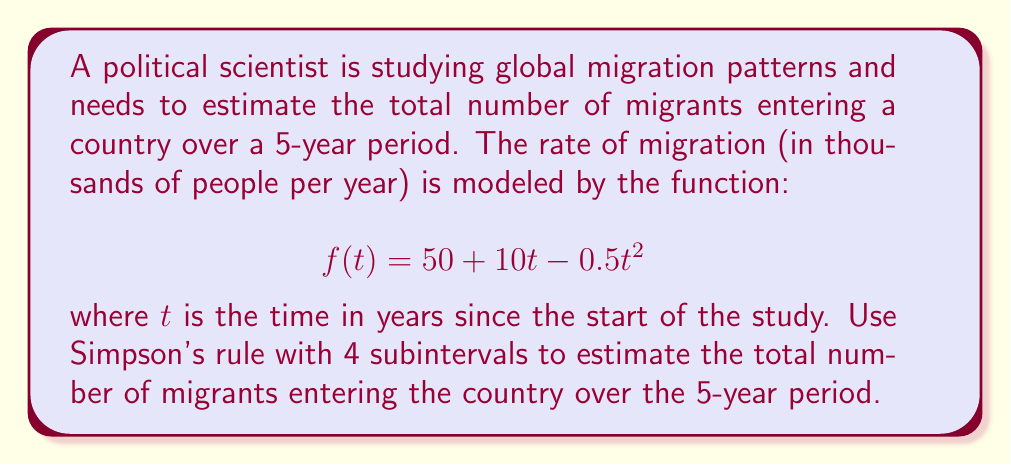Could you help me with this problem? To solve this problem, we'll use Simpson's rule for numerical integration. Simpson's rule approximates the definite integral of a function $f(x)$ over an interval $[a,b]$ using $n$ subintervals (where $n$ is even) as follows:

$$\int_a^b f(x) dx \approx \frac{h}{3}[f(x_0) + 4f(x_1) + 2f(x_2) + 4f(x_3) + ... + 2f(x_{n-2}) + 4f(x_{n-1}) + f(x_n)]$$

where $h = \frac{b-a}{n}$ is the width of each subinterval.

For our problem:
1. $a = 0$, $b = 5$ (5-year period)
2. $n = 4$ subintervals
3. $h = \frac{5-0}{4} = 1.25$ years

We need to evaluate $f(t)$ at $t = 0, 1.25, 2.5, 3.75,$ and $5$:

$f(0) = 50 + 10(0) - 0.5(0)^2 = 50$
$f(1.25) = 50 + 10(1.25) - 0.5(1.25)^2 = 61.09375$
$f(2.5) = 50 + 10(2.5) - 0.5(2.5)^2 = 68.75$
$f(3.75) = 50 + 10(3.75) - 0.5(3.75)^2 = 72.96875$
$f(5) = 50 + 10(5) - 0.5(5)^2 = 75$

Applying Simpson's rule:

$$\begin{aligned}
\int_0^5 f(t) dt &\approx \frac{1.25}{3}[f(0) + 4f(1.25) + 2f(2.5) + 4f(3.75) + f(5)] \\
&= \frac{1.25}{3}[50 + 4(61.09375) + 2(68.75) + 4(72.96875) + 75] \\
&= \frac{1.25}{3}[50 + 244.375 + 137.5 + 291.875 + 75] \\
&= \frac{1.25}{3}(798.75) \\
&= 332.8125
\end{aligned}$$

This result represents thousands of migrants, so we multiply by 1000 to get the total number of migrants.
Answer: The estimated total number of migrants entering the country over the 5-year period is approximately 332,813 people. 